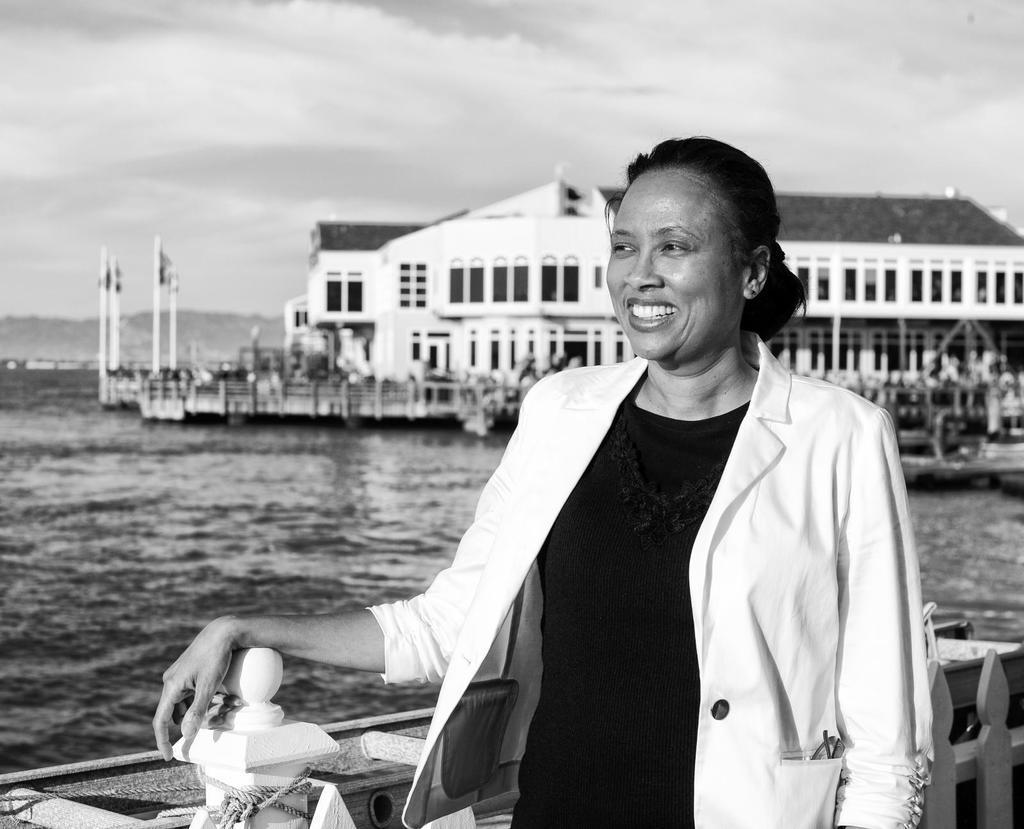Please provide a concise description of this image. In this image in the front there is a woman standing and smiling. In the center there is water. In the background there are buildings and the sky is cloudy. 